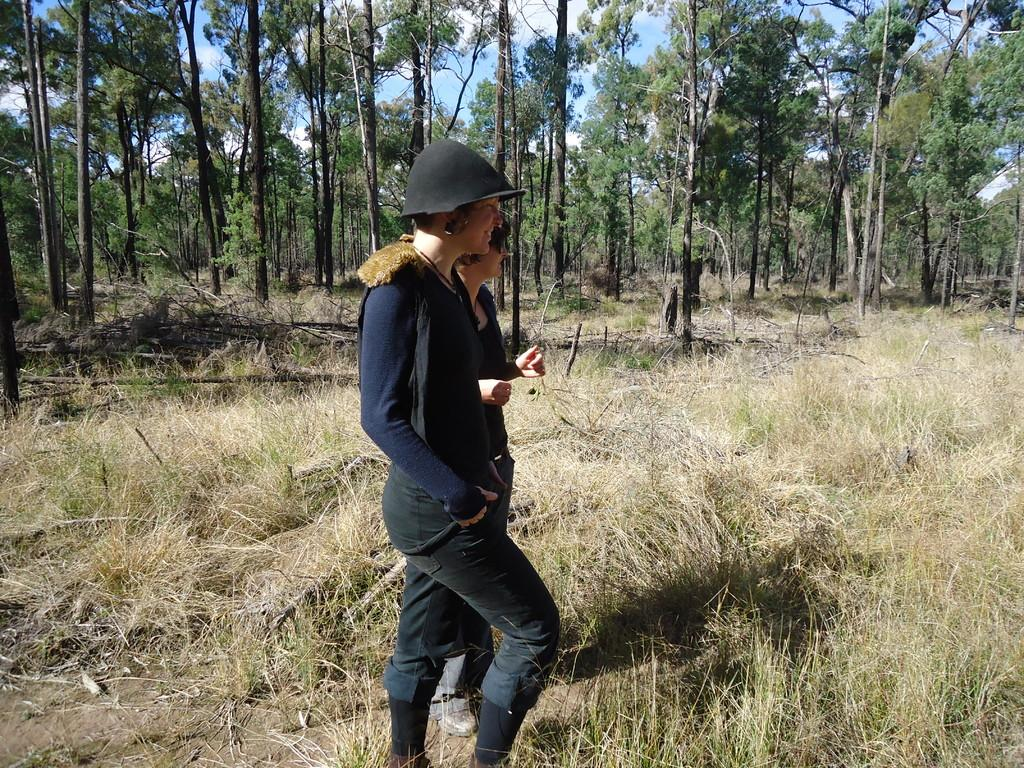How many people are in the image? There are two persons in the image. What are the persons wearing? Both persons are wearing black dress. What type of natural environment is visible in the image? There is grass visible in the image. What can be seen in the background of the image? There are trees in the background of the image. What type of soda is being consumed by the persons in the image? There is no soda present in the image; the persons are not consuming any beverages. What kind of pain is the person on the left experiencing in the image? There is no indication of pain or discomfort for either person in the image. 